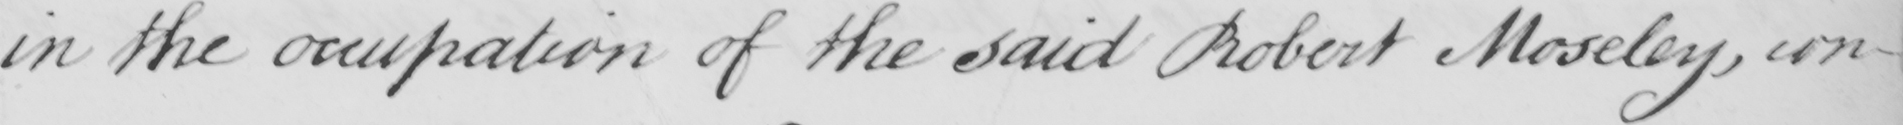Can you tell me what this handwritten text says? in the occupation of the said Robert Moseley , con- 